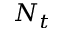Convert formula to latex. <formula><loc_0><loc_0><loc_500><loc_500>N _ { t }</formula> 